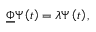Convert formula to latex. <formula><loc_0><loc_0><loc_500><loc_500>\underline { \Phi } \Psi \left ( t \right ) = \lambda \Psi \left ( t \right ) ,</formula> 